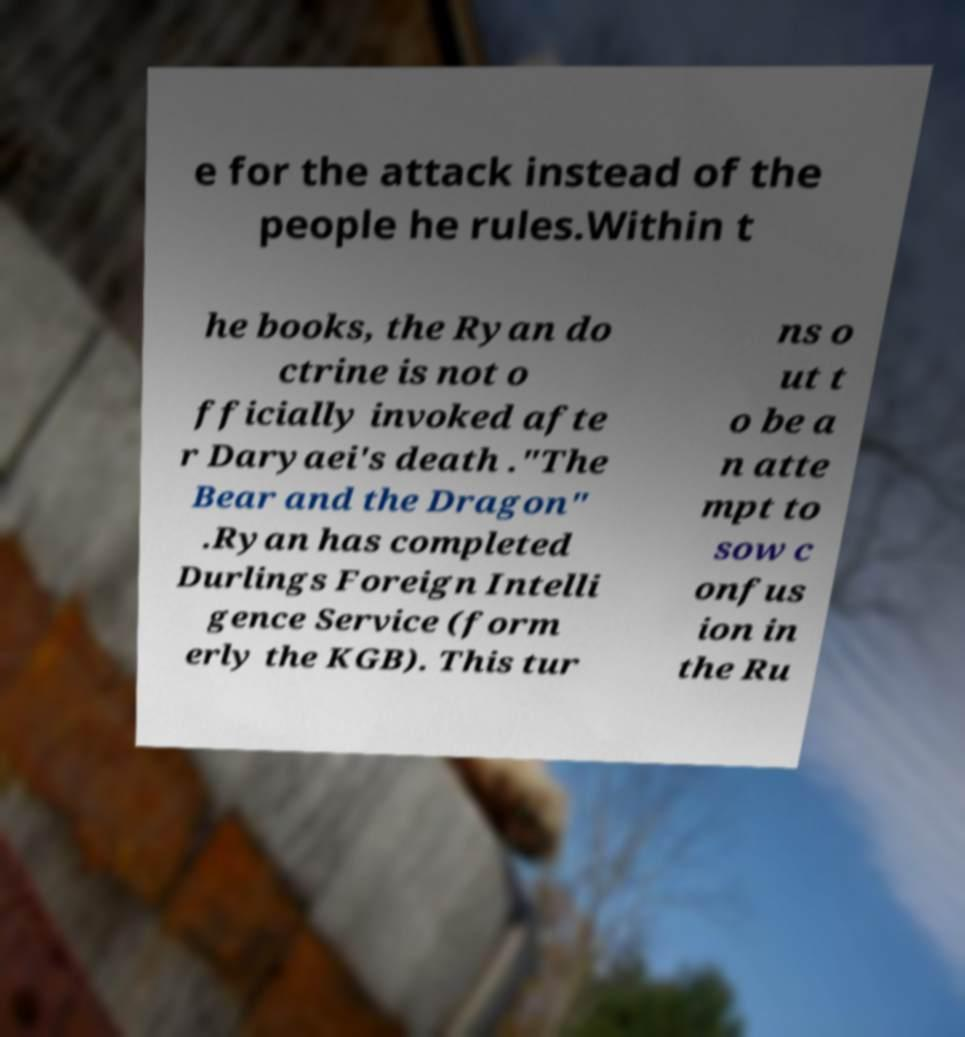I need the written content from this picture converted into text. Can you do that? e for the attack instead of the people he rules.Within t he books, the Ryan do ctrine is not o fficially invoked afte r Daryaei's death ."The Bear and the Dragon" .Ryan has completed Durlings Foreign Intelli gence Service (form erly the KGB). This tur ns o ut t o be a n atte mpt to sow c onfus ion in the Ru 